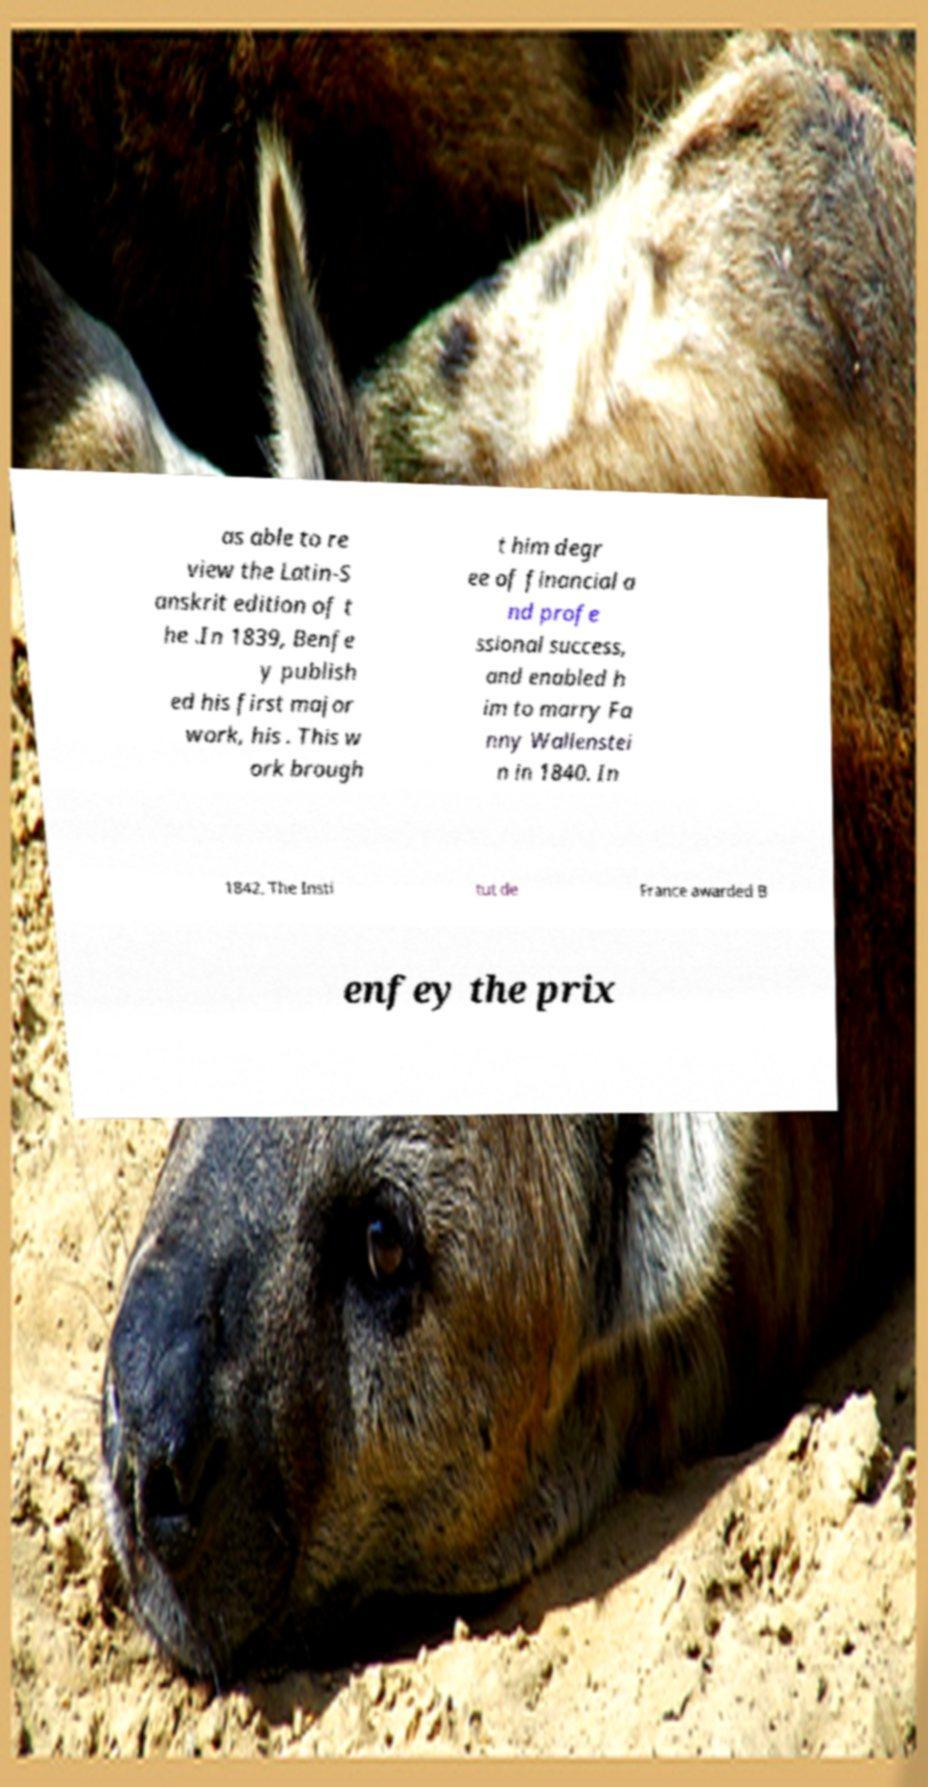Please identify and transcribe the text found in this image. as able to re view the Latin-S anskrit edition of t he .In 1839, Benfe y publish ed his first major work, his . This w ork brough t him degr ee of financial a nd profe ssional success, and enabled h im to marry Fa nny Wallenstei n in 1840. In 1842, The Insti tut de France awarded B enfey the prix 